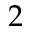<formula> <loc_0><loc_0><loc_500><loc_500>2</formula> 